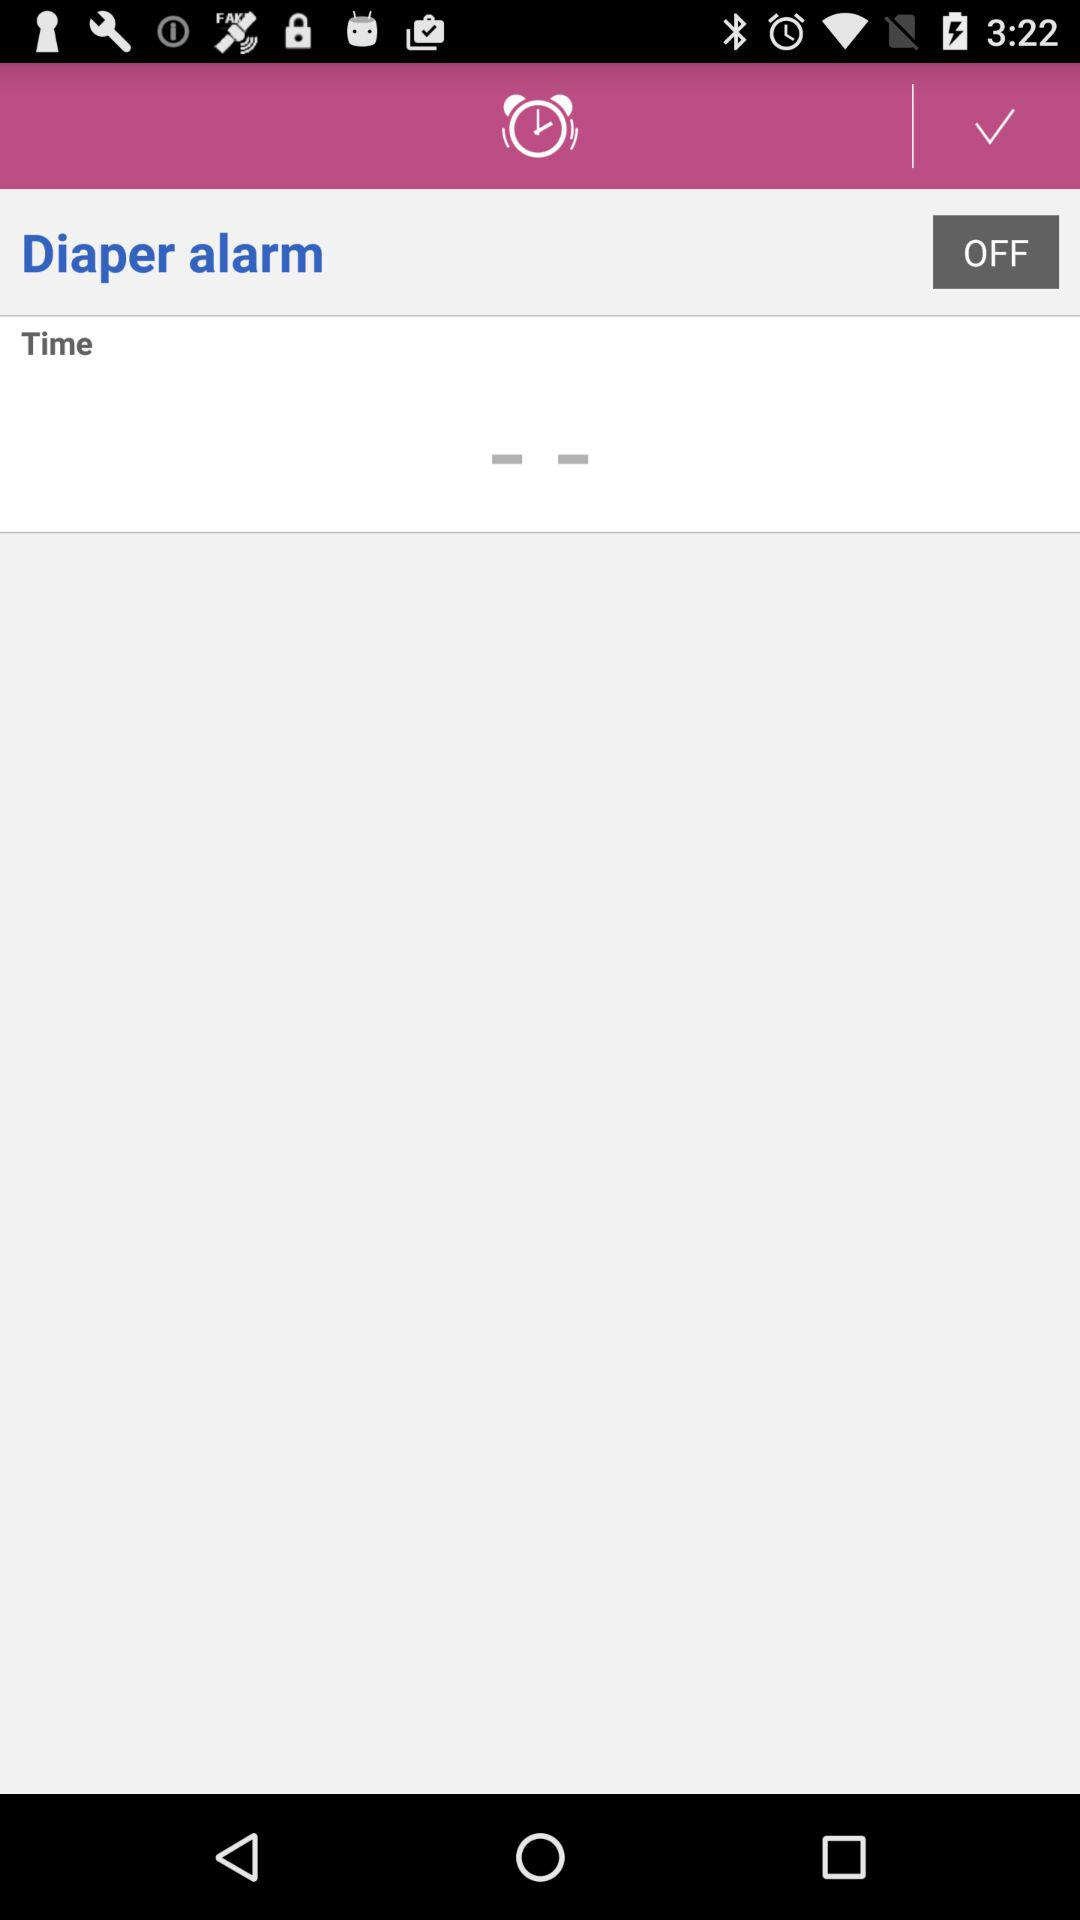What's the status of "Diaper alarm"? The status is "off". 